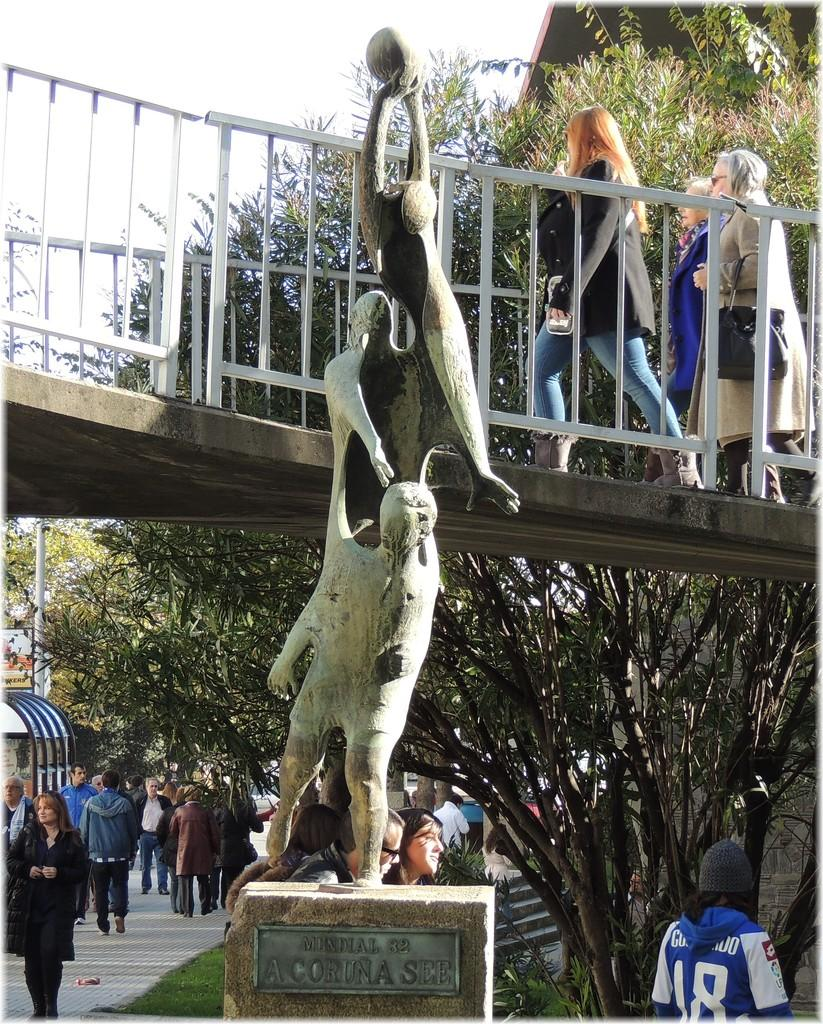<image>
Render a clear and concise summary of the photo. The tarnished plaque on a statue is inscribed with Mundial 82 A Coruna See. 